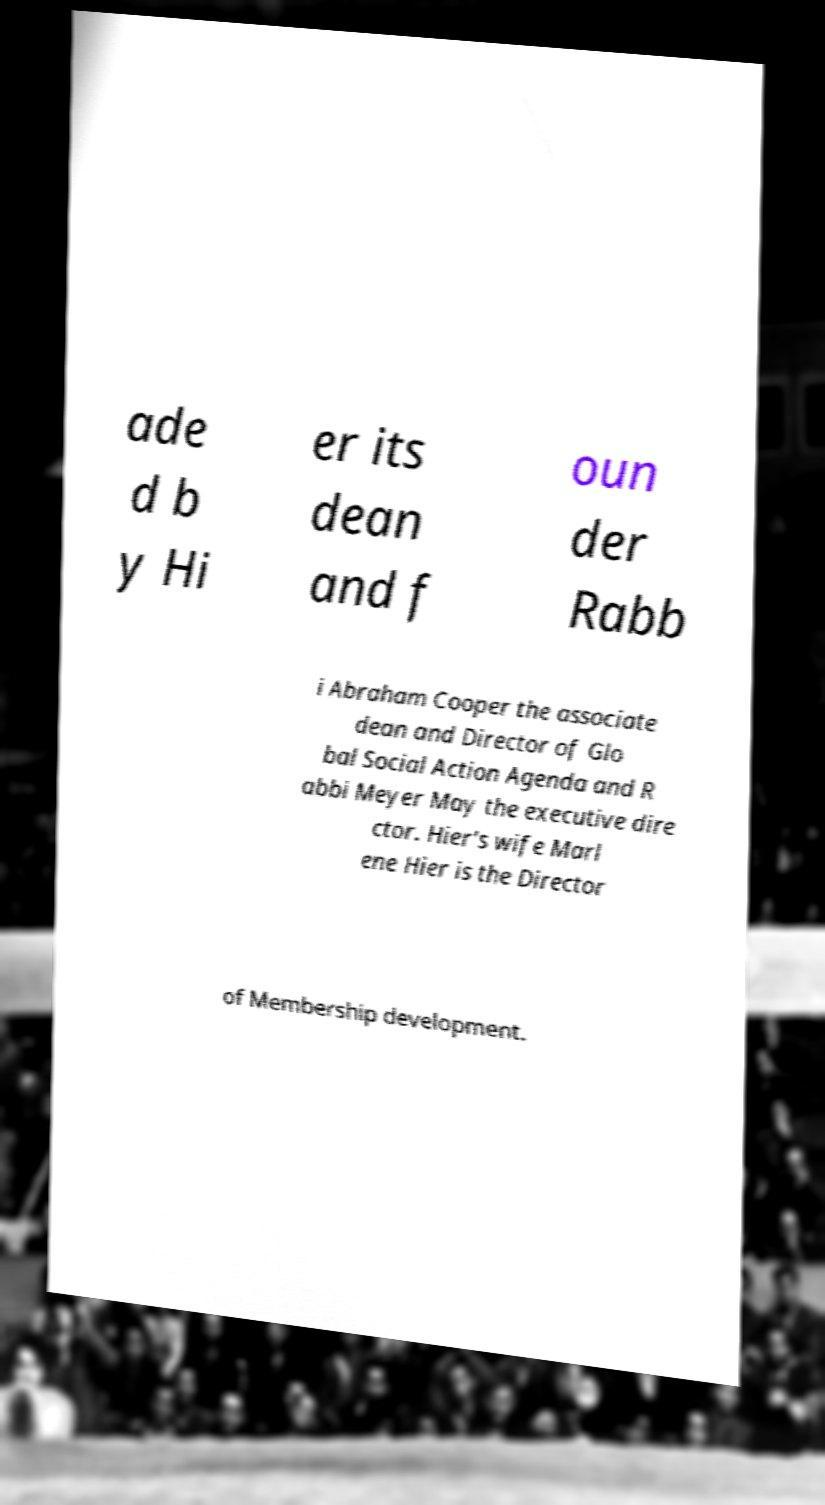Please read and relay the text visible in this image. What does it say? ade d b y Hi er its dean and f oun der Rabb i Abraham Cooper the associate dean and Director of Glo bal Social Action Agenda and R abbi Meyer May the executive dire ctor. Hier's wife Marl ene Hier is the Director of Membership development. 